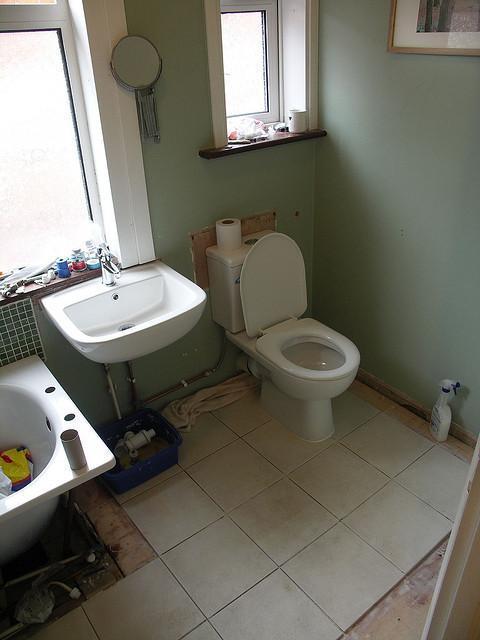How many people are facing the camera?
Give a very brief answer. 0. 